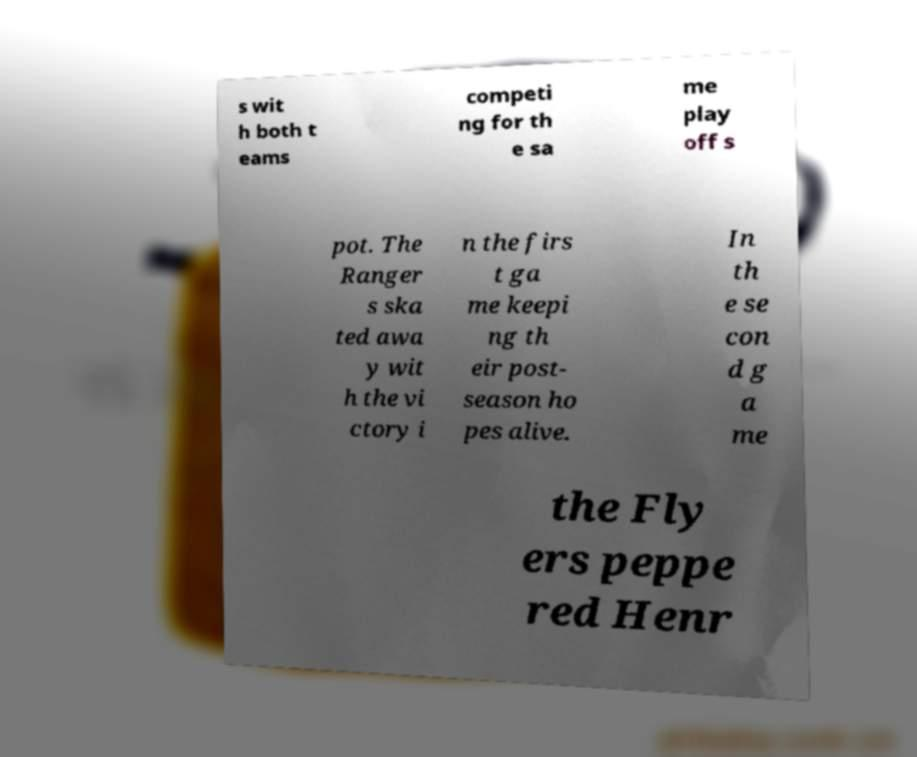For documentation purposes, I need the text within this image transcribed. Could you provide that? s wit h both t eams competi ng for th e sa me play off s pot. The Ranger s ska ted awa y wit h the vi ctory i n the firs t ga me keepi ng th eir post- season ho pes alive. In th e se con d g a me the Fly ers peppe red Henr 